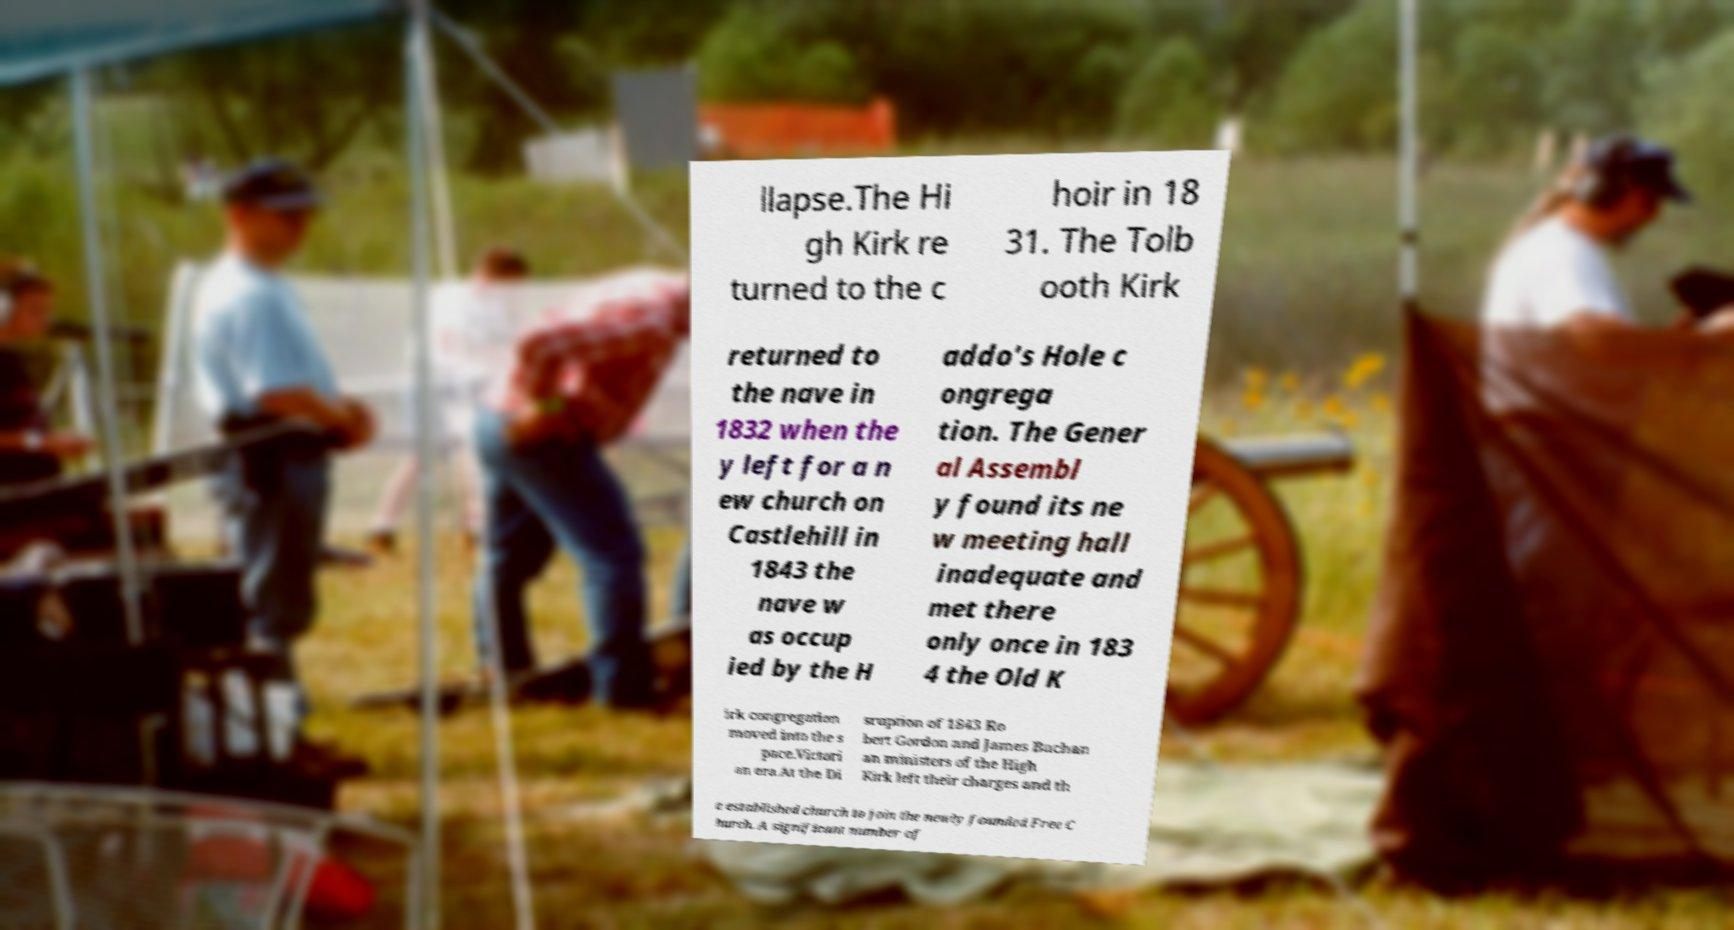Please read and relay the text visible in this image. What does it say? llapse.The Hi gh Kirk re turned to the c hoir in 18 31. The Tolb ooth Kirk returned to the nave in 1832 when the y left for a n ew church on Castlehill in 1843 the nave w as occup ied by the H addo's Hole c ongrega tion. The Gener al Assembl y found its ne w meeting hall inadequate and met there only once in 183 4 the Old K irk congregation moved into the s pace.Victori an era.At the Di sruption of 1843 Ro bert Gordon and James Buchan an ministers of the High Kirk left their charges and th e established church to join the newly founded Free C hurch. A significant number of 